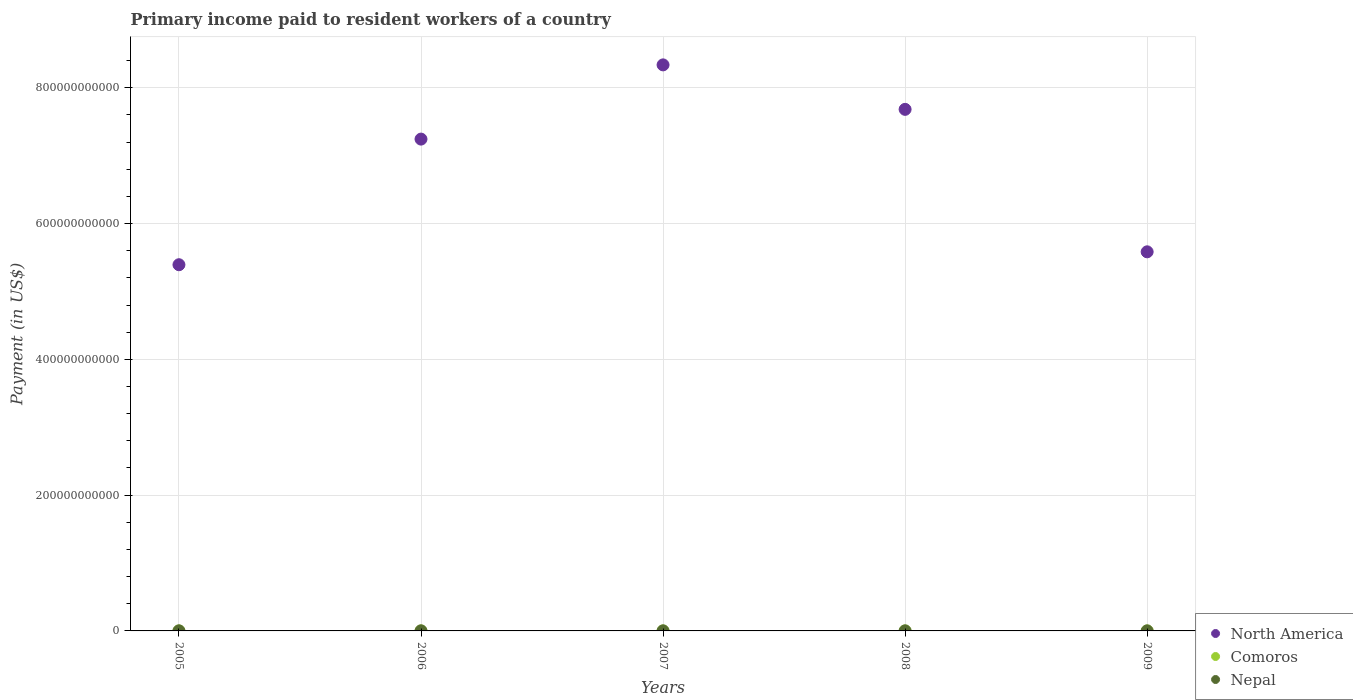What is the amount paid to workers in North America in 2009?
Your response must be concise. 5.58e+11. Across all years, what is the maximum amount paid to workers in Nepal?
Your answer should be very brief. 9.61e+07. Across all years, what is the minimum amount paid to workers in Nepal?
Offer a very short reply. 5.23e+07. What is the total amount paid to workers in Comoros in the graph?
Offer a very short reply. 2.65e+07. What is the difference between the amount paid to workers in North America in 2006 and that in 2007?
Offer a very short reply. -1.09e+11. What is the difference between the amount paid to workers in Nepal in 2006 and the amount paid to workers in Comoros in 2005?
Ensure brevity in your answer.  9.02e+07. What is the average amount paid to workers in Comoros per year?
Provide a short and direct response. 5.30e+06. In the year 2009, what is the difference between the amount paid to workers in Comoros and amount paid to workers in North America?
Your answer should be compact. -5.58e+11. What is the ratio of the amount paid to workers in North America in 2007 to that in 2009?
Your answer should be very brief. 1.49. Is the amount paid to workers in Nepal in 2005 less than that in 2008?
Make the answer very short. No. What is the difference between the highest and the second highest amount paid to workers in Nepal?
Offer a terse response. 4.50e+06. What is the difference between the highest and the lowest amount paid to workers in Comoros?
Offer a terse response. 3.56e+06. Is the sum of the amount paid to workers in Comoros in 2007 and 2009 greater than the maximum amount paid to workers in Nepal across all years?
Provide a short and direct response. No. Is it the case that in every year, the sum of the amount paid to workers in Nepal and amount paid to workers in Comoros  is greater than the amount paid to workers in North America?
Your answer should be very brief. No. Does the amount paid to workers in Comoros monotonically increase over the years?
Your answer should be compact. No. Is the amount paid to workers in Nepal strictly greater than the amount paid to workers in North America over the years?
Ensure brevity in your answer.  No. What is the difference between two consecutive major ticks on the Y-axis?
Ensure brevity in your answer.  2.00e+11. Does the graph contain any zero values?
Your answer should be very brief. No. Where does the legend appear in the graph?
Your answer should be very brief. Bottom right. What is the title of the graph?
Offer a very short reply. Primary income paid to resident workers of a country. What is the label or title of the X-axis?
Provide a short and direct response. Years. What is the label or title of the Y-axis?
Your answer should be compact. Payment (in US$). What is the Payment (in US$) in North America in 2005?
Your answer should be very brief. 5.39e+11. What is the Payment (in US$) of Comoros in 2005?
Ensure brevity in your answer.  5.90e+06. What is the Payment (in US$) of Nepal in 2005?
Your answer should be compact. 9.16e+07. What is the Payment (in US$) of North America in 2006?
Ensure brevity in your answer.  7.24e+11. What is the Payment (in US$) of Comoros in 2006?
Keep it short and to the point. 5.06e+06. What is the Payment (in US$) of Nepal in 2006?
Ensure brevity in your answer.  9.61e+07. What is the Payment (in US$) in North America in 2007?
Make the answer very short. 8.34e+11. What is the Payment (in US$) in Comoros in 2007?
Your answer should be very brief. 3.77e+06. What is the Payment (in US$) in Nepal in 2007?
Your answer should be very brief. 8.76e+07. What is the Payment (in US$) of North America in 2008?
Keep it short and to the point. 7.68e+11. What is the Payment (in US$) of Comoros in 2008?
Offer a terse response. 7.33e+06. What is the Payment (in US$) in Nepal in 2008?
Keep it short and to the point. 8.46e+07. What is the Payment (in US$) in North America in 2009?
Offer a terse response. 5.58e+11. What is the Payment (in US$) in Comoros in 2009?
Keep it short and to the point. 4.43e+06. What is the Payment (in US$) in Nepal in 2009?
Provide a succinct answer. 5.23e+07. Across all years, what is the maximum Payment (in US$) in North America?
Keep it short and to the point. 8.34e+11. Across all years, what is the maximum Payment (in US$) in Comoros?
Ensure brevity in your answer.  7.33e+06. Across all years, what is the maximum Payment (in US$) in Nepal?
Give a very brief answer. 9.61e+07. Across all years, what is the minimum Payment (in US$) of North America?
Your answer should be compact. 5.39e+11. Across all years, what is the minimum Payment (in US$) in Comoros?
Your answer should be very brief. 3.77e+06. Across all years, what is the minimum Payment (in US$) of Nepal?
Your answer should be compact. 5.23e+07. What is the total Payment (in US$) in North America in the graph?
Your answer should be compact. 3.42e+12. What is the total Payment (in US$) of Comoros in the graph?
Your answer should be very brief. 2.65e+07. What is the total Payment (in US$) of Nepal in the graph?
Make the answer very short. 4.12e+08. What is the difference between the Payment (in US$) in North America in 2005 and that in 2006?
Provide a short and direct response. -1.85e+11. What is the difference between the Payment (in US$) of Comoros in 2005 and that in 2006?
Give a very brief answer. 8.37e+05. What is the difference between the Payment (in US$) of Nepal in 2005 and that in 2006?
Give a very brief answer. -4.50e+06. What is the difference between the Payment (in US$) of North America in 2005 and that in 2007?
Give a very brief answer. -2.94e+11. What is the difference between the Payment (in US$) of Comoros in 2005 and that in 2007?
Keep it short and to the point. 2.13e+06. What is the difference between the Payment (in US$) of Nepal in 2005 and that in 2007?
Give a very brief answer. 3.95e+06. What is the difference between the Payment (in US$) in North America in 2005 and that in 2008?
Ensure brevity in your answer.  -2.29e+11. What is the difference between the Payment (in US$) in Comoros in 2005 and that in 2008?
Offer a very short reply. -1.43e+06. What is the difference between the Payment (in US$) of Nepal in 2005 and that in 2008?
Give a very brief answer. 6.93e+06. What is the difference between the Payment (in US$) in North America in 2005 and that in 2009?
Your response must be concise. -1.90e+1. What is the difference between the Payment (in US$) in Comoros in 2005 and that in 2009?
Give a very brief answer. 1.47e+06. What is the difference between the Payment (in US$) of Nepal in 2005 and that in 2009?
Give a very brief answer. 3.93e+07. What is the difference between the Payment (in US$) in North America in 2006 and that in 2007?
Keep it short and to the point. -1.09e+11. What is the difference between the Payment (in US$) of Comoros in 2006 and that in 2007?
Provide a succinct answer. 1.29e+06. What is the difference between the Payment (in US$) of Nepal in 2006 and that in 2007?
Offer a terse response. 8.45e+06. What is the difference between the Payment (in US$) of North America in 2006 and that in 2008?
Make the answer very short. -4.38e+1. What is the difference between the Payment (in US$) of Comoros in 2006 and that in 2008?
Your response must be concise. -2.27e+06. What is the difference between the Payment (in US$) in Nepal in 2006 and that in 2008?
Ensure brevity in your answer.  1.14e+07. What is the difference between the Payment (in US$) in North America in 2006 and that in 2009?
Your response must be concise. 1.66e+11. What is the difference between the Payment (in US$) in Comoros in 2006 and that in 2009?
Make the answer very short. 6.29e+05. What is the difference between the Payment (in US$) of Nepal in 2006 and that in 2009?
Provide a succinct answer. 4.38e+07. What is the difference between the Payment (in US$) of North America in 2007 and that in 2008?
Offer a very short reply. 6.55e+1. What is the difference between the Payment (in US$) of Comoros in 2007 and that in 2008?
Give a very brief answer. -3.56e+06. What is the difference between the Payment (in US$) of Nepal in 2007 and that in 2008?
Ensure brevity in your answer.  2.98e+06. What is the difference between the Payment (in US$) of North America in 2007 and that in 2009?
Provide a short and direct response. 2.75e+11. What is the difference between the Payment (in US$) of Comoros in 2007 and that in 2009?
Ensure brevity in your answer.  -6.64e+05. What is the difference between the Payment (in US$) of Nepal in 2007 and that in 2009?
Give a very brief answer. 3.53e+07. What is the difference between the Payment (in US$) of North America in 2008 and that in 2009?
Offer a very short reply. 2.10e+11. What is the difference between the Payment (in US$) in Comoros in 2008 and that in 2009?
Keep it short and to the point. 2.90e+06. What is the difference between the Payment (in US$) of Nepal in 2008 and that in 2009?
Provide a short and direct response. 3.23e+07. What is the difference between the Payment (in US$) in North America in 2005 and the Payment (in US$) in Comoros in 2006?
Give a very brief answer. 5.39e+11. What is the difference between the Payment (in US$) of North America in 2005 and the Payment (in US$) of Nepal in 2006?
Your answer should be very brief. 5.39e+11. What is the difference between the Payment (in US$) in Comoros in 2005 and the Payment (in US$) in Nepal in 2006?
Make the answer very short. -9.02e+07. What is the difference between the Payment (in US$) of North America in 2005 and the Payment (in US$) of Comoros in 2007?
Keep it short and to the point. 5.39e+11. What is the difference between the Payment (in US$) of North America in 2005 and the Payment (in US$) of Nepal in 2007?
Provide a short and direct response. 5.39e+11. What is the difference between the Payment (in US$) of Comoros in 2005 and the Payment (in US$) of Nepal in 2007?
Your answer should be compact. -8.17e+07. What is the difference between the Payment (in US$) in North America in 2005 and the Payment (in US$) in Comoros in 2008?
Provide a short and direct response. 5.39e+11. What is the difference between the Payment (in US$) in North America in 2005 and the Payment (in US$) in Nepal in 2008?
Ensure brevity in your answer.  5.39e+11. What is the difference between the Payment (in US$) in Comoros in 2005 and the Payment (in US$) in Nepal in 2008?
Keep it short and to the point. -7.87e+07. What is the difference between the Payment (in US$) in North America in 2005 and the Payment (in US$) in Comoros in 2009?
Give a very brief answer. 5.39e+11. What is the difference between the Payment (in US$) in North America in 2005 and the Payment (in US$) in Nepal in 2009?
Offer a very short reply. 5.39e+11. What is the difference between the Payment (in US$) in Comoros in 2005 and the Payment (in US$) in Nepal in 2009?
Your response must be concise. -4.64e+07. What is the difference between the Payment (in US$) in North America in 2006 and the Payment (in US$) in Comoros in 2007?
Keep it short and to the point. 7.24e+11. What is the difference between the Payment (in US$) of North America in 2006 and the Payment (in US$) of Nepal in 2007?
Keep it short and to the point. 7.24e+11. What is the difference between the Payment (in US$) in Comoros in 2006 and the Payment (in US$) in Nepal in 2007?
Make the answer very short. -8.25e+07. What is the difference between the Payment (in US$) in North America in 2006 and the Payment (in US$) in Comoros in 2008?
Ensure brevity in your answer.  7.24e+11. What is the difference between the Payment (in US$) of North America in 2006 and the Payment (in US$) of Nepal in 2008?
Offer a very short reply. 7.24e+11. What is the difference between the Payment (in US$) in Comoros in 2006 and the Payment (in US$) in Nepal in 2008?
Provide a short and direct response. -7.96e+07. What is the difference between the Payment (in US$) in North America in 2006 and the Payment (in US$) in Comoros in 2009?
Your answer should be compact. 7.24e+11. What is the difference between the Payment (in US$) of North America in 2006 and the Payment (in US$) of Nepal in 2009?
Ensure brevity in your answer.  7.24e+11. What is the difference between the Payment (in US$) of Comoros in 2006 and the Payment (in US$) of Nepal in 2009?
Make the answer very short. -4.72e+07. What is the difference between the Payment (in US$) in North America in 2007 and the Payment (in US$) in Comoros in 2008?
Your response must be concise. 8.34e+11. What is the difference between the Payment (in US$) of North America in 2007 and the Payment (in US$) of Nepal in 2008?
Offer a terse response. 8.34e+11. What is the difference between the Payment (in US$) in Comoros in 2007 and the Payment (in US$) in Nepal in 2008?
Your response must be concise. -8.09e+07. What is the difference between the Payment (in US$) in North America in 2007 and the Payment (in US$) in Comoros in 2009?
Ensure brevity in your answer.  8.34e+11. What is the difference between the Payment (in US$) in North America in 2007 and the Payment (in US$) in Nepal in 2009?
Your response must be concise. 8.34e+11. What is the difference between the Payment (in US$) in Comoros in 2007 and the Payment (in US$) in Nepal in 2009?
Your response must be concise. -4.85e+07. What is the difference between the Payment (in US$) in North America in 2008 and the Payment (in US$) in Comoros in 2009?
Ensure brevity in your answer.  7.68e+11. What is the difference between the Payment (in US$) in North America in 2008 and the Payment (in US$) in Nepal in 2009?
Offer a terse response. 7.68e+11. What is the difference between the Payment (in US$) of Comoros in 2008 and the Payment (in US$) of Nepal in 2009?
Provide a short and direct response. -4.50e+07. What is the average Payment (in US$) in North America per year?
Offer a very short reply. 6.85e+11. What is the average Payment (in US$) in Comoros per year?
Offer a very short reply. 5.30e+06. What is the average Payment (in US$) in Nepal per year?
Provide a succinct answer. 8.24e+07. In the year 2005, what is the difference between the Payment (in US$) in North America and Payment (in US$) in Comoros?
Ensure brevity in your answer.  5.39e+11. In the year 2005, what is the difference between the Payment (in US$) of North America and Payment (in US$) of Nepal?
Your answer should be very brief. 5.39e+11. In the year 2005, what is the difference between the Payment (in US$) in Comoros and Payment (in US$) in Nepal?
Provide a succinct answer. -8.57e+07. In the year 2006, what is the difference between the Payment (in US$) of North America and Payment (in US$) of Comoros?
Provide a succinct answer. 7.24e+11. In the year 2006, what is the difference between the Payment (in US$) in North America and Payment (in US$) in Nepal?
Your answer should be compact. 7.24e+11. In the year 2006, what is the difference between the Payment (in US$) in Comoros and Payment (in US$) in Nepal?
Make the answer very short. -9.10e+07. In the year 2007, what is the difference between the Payment (in US$) of North America and Payment (in US$) of Comoros?
Offer a very short reply. 8.34e+11. In the year 2007, what is the difference between the Payment (in US$) in North America and Payment (in US$) in Nepal?
Provide a short and direct response. 8.34e+11. In the year 2007, what is the difference between the Payment (in US$) in Comoros and Payment (in US$) in Nepal?
Your answer should be compact. -8.38e+07. In the year 2008, what is the difference between the Payment (in US$) of North America and Payment (in US$) of Comoros?
Give a very brief answer. 7.68e+11. In the year 2008, what is the difference between the Payment (in US$) in North America and Payment (in US$) in Nepal?
Ensure brevity in your answer.  7.68e+11. In the year 2008, what is the difference between the Payment (in US$) of Comoros and Payment (in US$) of Nepal?
Your answer should be very brief. -7.73e+07. In the year 2009, what is the difference between the Payment (in US$) in North America and Payment (in US$) in Comoros?
Make the answer very short. 5.58e+11. In the year 2009, what is the difference between the Payment (in US$) in North America and Payment (in US$) in Nepal?
Make the answer very short. 5.58e+11. In the year 2009, what is the difference between the Payment (in US$) in Comoros and Payment (in US$) in Nepal?
Make the answer very short. -4.79e+07. What is the ratio of the Payment (in US$) in North America in 2005 to that in 2006?
Your answer should be compact. 0.74. What is the ratio of the Payment (in US$) in Comoros in 2005 to that in 2006?
Keep it short and to the point. 1.17. What is the ratio of the Payment (in US$) of Nepal in 2005 to that in 2006?
Ensure brevity in your answer.  0.95. What is the ratio of the Payment (in US$) in North America in 2005 to that in 2007?
Provide a succinct answer. 0.65. What is the ratio of the Payment (in US$) of Comoros in 2005 to that in 2007?
Provide a succinct answer. 1.57. What is the ratio of the Payment (in US$) of Nepal in 2005 to that in 2007?
Keep it short and to the point. 1.05. What is the ratio of the Payment (in US$) of North America in 2005 to that in 2008?
Offer a very short reply. 0.7. What is the ratio of the Payment (in US$) in Comoros in 2005 to that in 2008?
Make the answer very short. 0.8. What is the ratio of the Payment (in US$) of Nepal in 2005 to that in 2008?
Make the answer very short. 1.08. What is the ratio of the Payment (in US$) of North America in 2005 to that in 2009?
Make the answer very short. 0.97. What is the ratio of the Payment (in US$) in Comoros in 2005 to that in 2009?
Ensure brevity in your answer.  1.33. What is the ratio of the Payment (in US$) of Nepal in 2005 to that in 2009?
Your response must be concise. 1.75. What is the ratio of the Payment (in US$) of North America in 2006 to that in 2007?
Provide a succinct answer. 0.87. What is the ratio of the Payment (in US$) of Comoros in 2006 to that in 2007?
Give a very brief answer. 1.34. What is the ratio of the Payment (in US$) in Nepal in 2006 to that in 2007?
Keep it short and to the point. 1.1. What is the ratio of the Payment (in US$) of North America in 2006 to that in 2008?
Your answer should be compact. 0.94. What is the ratio of the Payment (in US$) in Comoros in 2006 to that in 2008?
Ensure brevity in your answer.  0.69. What is the ratio of the Payment (in US$) in Nepal in 2006 to that in 2008?
Your response must be concise. 1.14. What is the ratio of the Payment (in US$) of North America in 2006 to that in 2009?
Keep it short and to the point. 1.3. What is the ratio of the Payment (in US$) of Comoros in 2006 to that in 2009?
Offer a very short reply. 1.14. What is the ratio of the Payment (in US$) of Nepal in 2006 to that in 2009?
Give a very brief answer. 1.84. What is the ratio of the Payment (in US$) of North America in 2007 to that in 2008?
Provide a succinct answer. 1.09. What is the ratio of the Payment (in US$) of Comoros in 2007 to that in 2008?
Your answer should be very brief. 0.51. What is the ratio of the Payment (in US$) of Nepal in 2007 to that in 2008?
Provide a short and direct response. 1.04. What is the ratio of the Payment (in US$) in North America in 2007 to that in 2009?
Offer a very short reply. 1.49. What is the ratio of the Payment (in US$) in Comoros in 2007 to that in 2009?
Your response must be concise. 0.85. What is the ratio of the Payment (in US$) of Nepal in 2007 to that in 2009?
Offer a terse response. 1.68. What is the ratio of the Payment (in US$) of North America in 2008 to that in 2009?
Offer a very short reply. 1.38. What is the ratio of the Payment (in US$) in Comoros in 2008 to that in 2009?
Your response must be concise. 1.65. What is the ratio of the Payment (in US$) in Nepal in 2008 to that in 2009?
Offer a very short reply. 1.62. What is the difference between the highest and the second highest Payment (in US$) of North America?
Keep it short and to the point. 6.55e+1. What is the difference between the highest and the second highest Payment (in US$) of Comoros?
Keep it short and to the point. 1.43e+06. What is the difference between the highest and the second highest Payment (in US$) of Nepal?
Offer a very short reply. 4.50e+06. What is the difference between the highest and the lowest Payment (in US$) of North America?
Provide a short and direct response. 2.94e+11. What is the difference between the highest and the lowest Payment (in US$) of Comoros?
Provide a succinct answer. 3.56e+06. What is the difference between the highest and the lowest Payment (in US$) of Nepal?
Keep it short and to the point. 4.38e+07. 